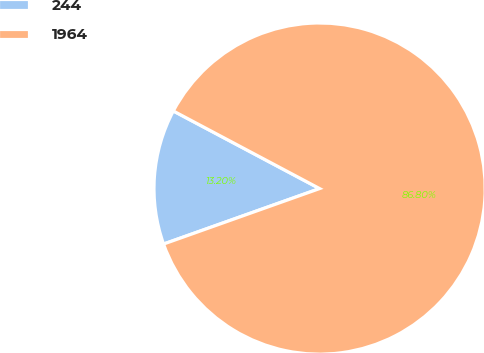Convert chart to OTSL. <chart><loc_0><loc_0><loc_500><loc_500><pie_chart><fcel>244<fcel>1964<nl><fcel>13.2%<fcel>86.8%<nl></chart> 